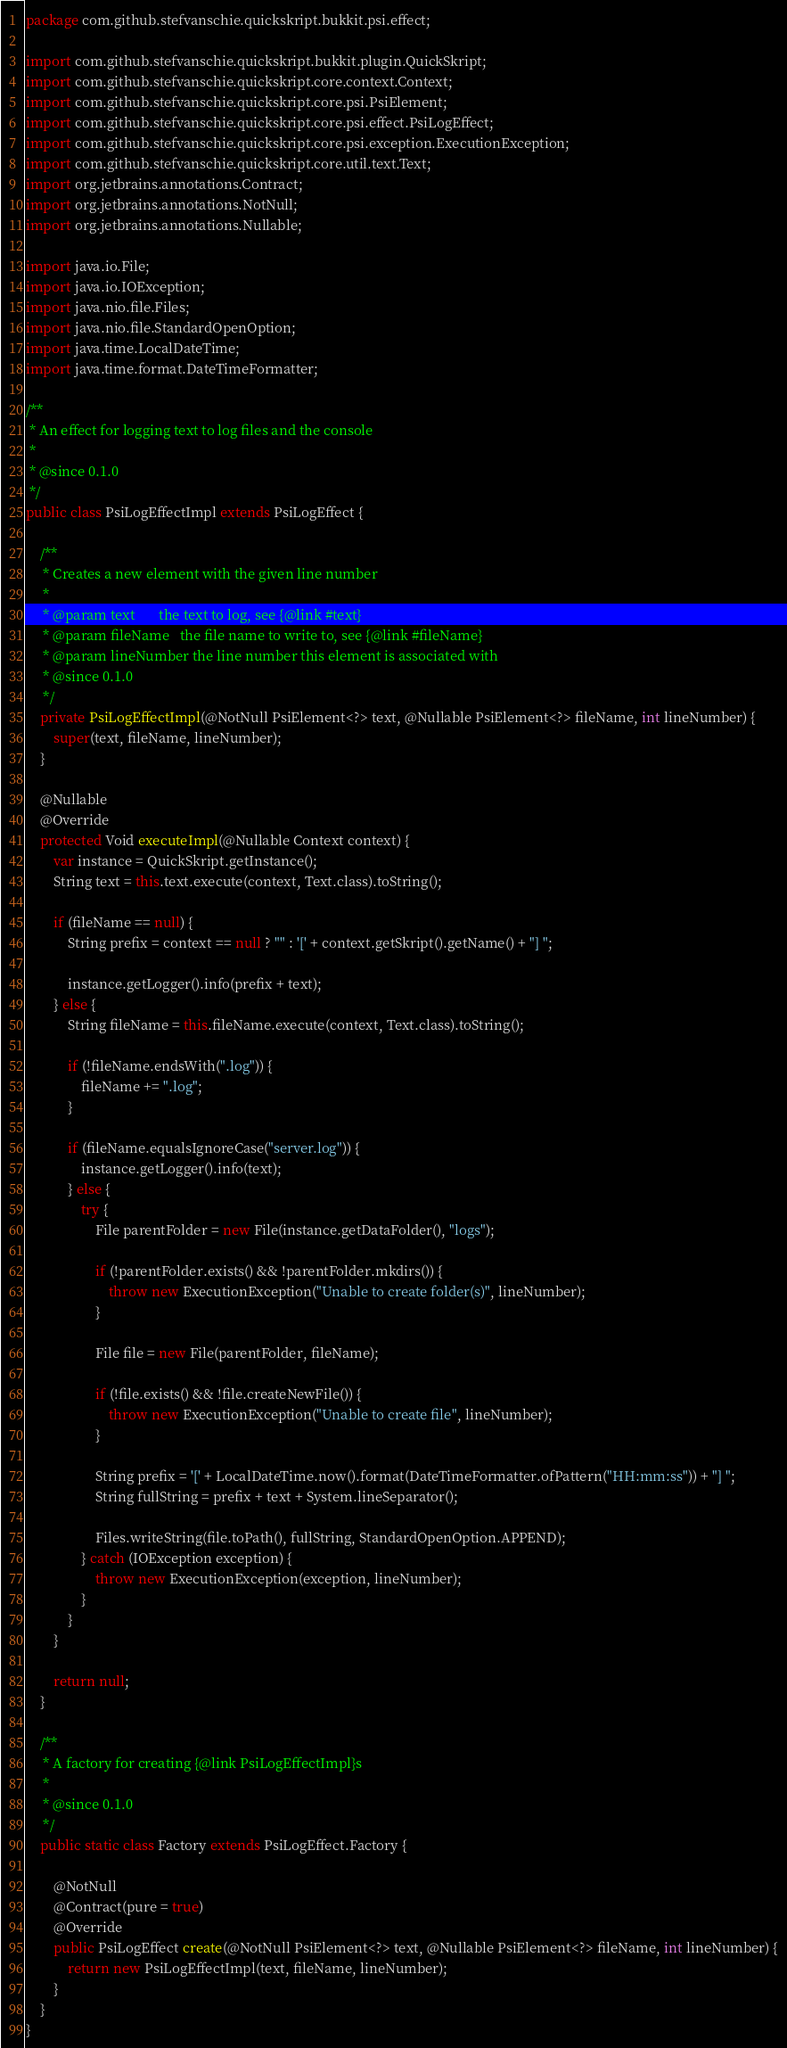<code> <loc_0><loc_0><loc_500><loc_500><_Java_>package com.github.stefvanschie.quickskript.bukkit.psi.effect;

import com.github.stefvanschie.quickskript.bukkit.plugin.QuickSkript;
import com.github.stefvanschie.quickskript.core.context.Context;
import com.github.stefvanschie.quickskript.core.psi.PsiElement;
import com.github.stefvanschie.quickskript.core.psi.effect.PsiLogEffect;
import com.github.stefvanschie.quickskript.core.psi.exception.ExecutionException;
import com.github.stefvanschie.quickskript.core.util.text.Text;
import org.jetbrains.annotations.Contract;
import org.jetbrains.annotations.NotNull;
import org.jetbrains.annotations.Nullable;

import java.io.File;
import java.io.IOException;
import java.nio.file.Files;
import java.nio.file.StandardOpenOption;
import java.time.LocalDateTime;
import java.time.format.DateTimeFormatter;

/**
 * An effect for logging text to log files and the console
 *
 * @since 0.1.0
 */
public class PsiLogEffectImpl extends PsiLogEffect {

    /**
     * Creates a new element with the given line number
     *
     * @param text       the text to log, see {@link #text}
     * @param fileName   the file name to write to, see {@link #fileName}
     * @param lineNumber the line number this element is associated with
     * @since 0.1.0
     */
    private PsiLogEffectImpl(@NotNull PsiElement<?> text, @Nullable PsiElement<?> fileName, int lineNumber) {
        super(text, fileName, lineNumber);
    }

    @Nullable
    @Override
    protected Void executeImpl(@Nullable Context context) {
        var instance = QuickSkript.getInstance();
        String text = this.text.execute(context, Text.class).toString();

        if (fileName == null) {
            String prefix = context == null ? "" : '[' + context.getSkript().getName() + "] ";

            instance.getLogger().info(prefix + text);
        } else {
            String fileName = this.fileName.execute(context, Text.class).toString();

            if (!fileName.endsWith(".log")) {
                fileName += ".log";
            }

            if (fileName.equalsIgnoreCase("server.log")) {
                instance.getLogger().info(text);
            } else {
                try {
                    File parentFolder = new File(instance.getDataFolder(), "logs");

                    if (!parentFolder.exists() && !parentFolder.mkdirs()) {
                        throw new ExecutionException("Unable to create folder(s)", lineNumber);
                    }

                    File file = new File(parentFolder, fileName);

                    if (!file.exists() && !file.createNewFile()) {
                        throw new ExecutionException("Unable to create file", lineNumber);
                    }

                    String prefix = '[' + LocalDateTime.now().format(DateTimeFormatter.ofPattern("HH:mm:ss")) + "] ";
                    String fullString = prefix + text + System.lineSeparator();

                    Files.writeString(file.toPath(), fullString, StandardOpenOption.APPEND);
                } catch (IOException exception) {
                    throw new ExecutionException(exception, lineNumber);
                }
            }
        }

        return null;
    }

    /**
     * A factory for creating {@link PsiLogEffectImpl}s
     *
     * @since 0.1.0
     */
    public static class Factory extends PsiLogEffect.Factory {

        @NotNull
        @Contract(pure = true)
        @Override
        public PsiLogEffect create(@NotNull PsiElement<?> text, @Nullable PsiElement<?> fileName, int lineNumber) {
            return new PsiLogEffectImpl(text, fileName, lineNumber);
        }
    }
}
</code> 